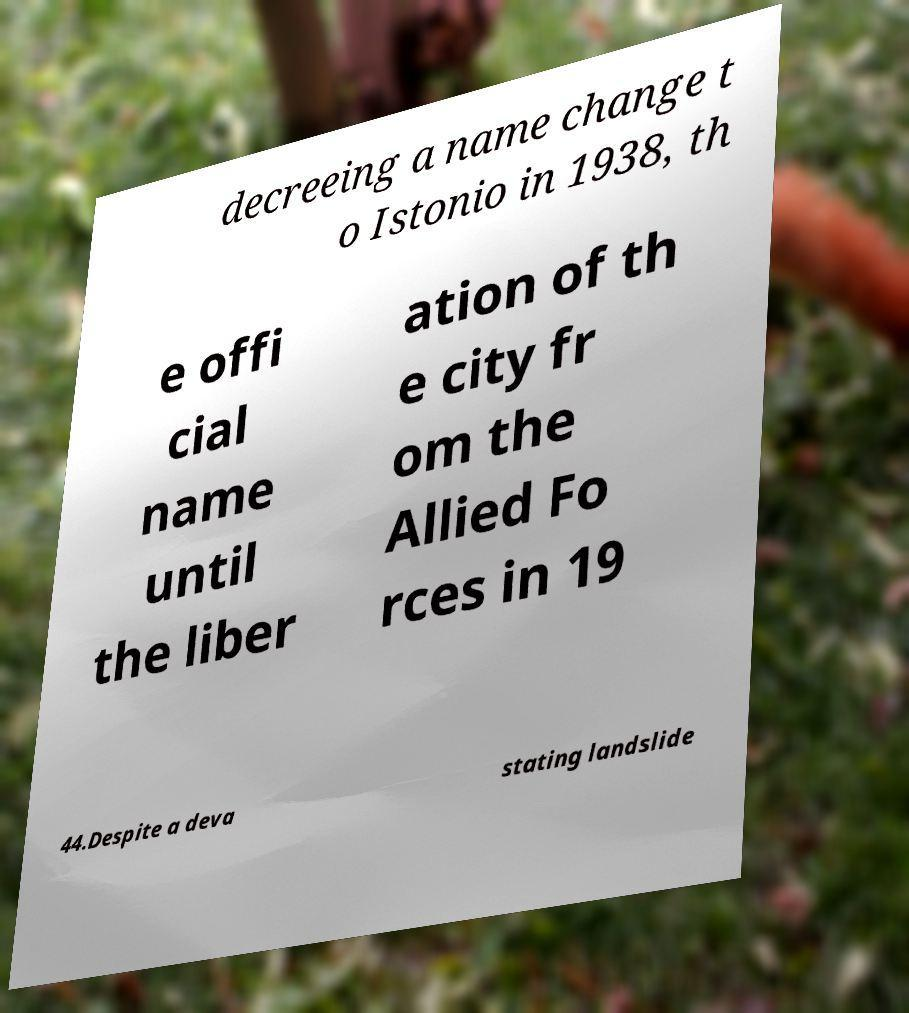Can you read and provide the text displayed in the image?This photo seems to have some interesting text. Can you extract and type it out for me? decreeing a name change t o Istonio in 1938, th e offi cial name until the liber ation of th e city fr om the Allied Fo rces in 19 44.Despite a deva stating landslide 